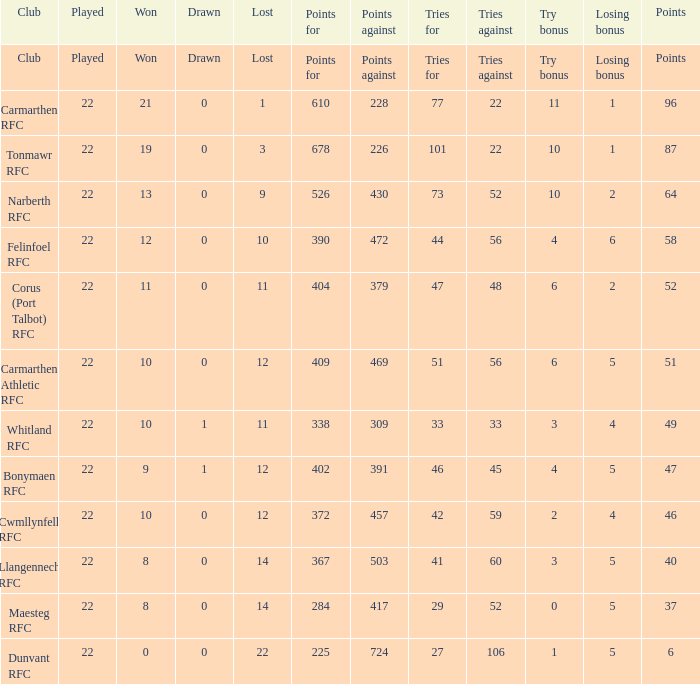Name the tries against for drawn 1.0. 